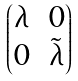<formula> <loc_0><loc_0><loc_500><loc_500>\begin{pmatrix} \lambda & 0 \\ 0 & \tilde { \lambda } \end{pmatrix}</formula> 